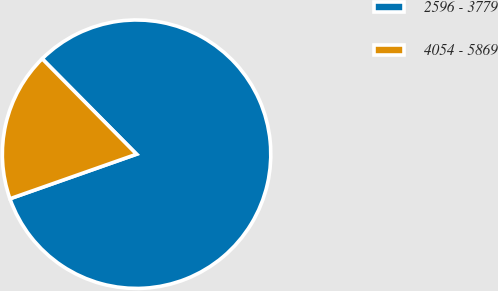Convert chart to OTSL. <chart><loc_0><loc_0><loc_500><loc_500><pie_chart><fcel>2596 - 3779<fcel>4054 - 5869<nl><fcel>82.03%<fcel>17.97%<nl></chart> 